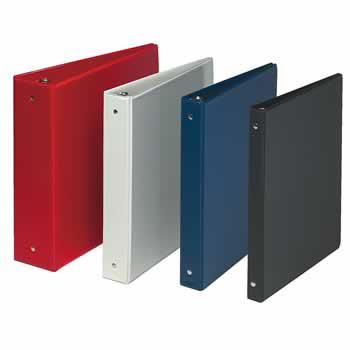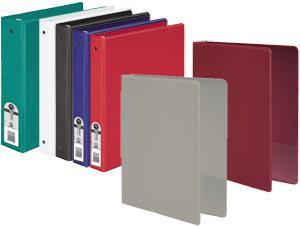The first image is the image on the left, the second image is the image on the right. Given the left and right images, does the statement "All binders are the base color white and there are at least five present." hold true? Answer yes or no. No. The first image is the image on the left, the second image is the image on the right. Examine the images to the left and right. Is the description "All binders shown are white and all binders are displayed upright." accurate? Answer yes or no. No. 